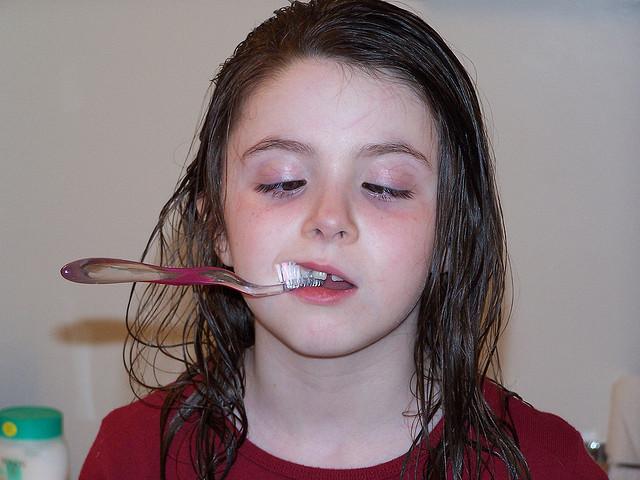What color is her shirt?
Concise answer only. Red. What is the woman doing?
Short answer required. Brushing teeth. Is she brushing?
Concise answer only. Yes. What is she doing?
Be succinct. Brushing teeth. Why are the scissor handles purple?
Give a very brief answer. No scissors. Is this girl's hair a natural color?
Answer briefly. Yes. What color is the girl's shirt?
Give a very brief answer. Red. How many bottles are pictured?
Concise answer only. 1. Is she really brushing her teeth?
Answer briefly. No. Which way is the girl looking?
Be succinct. Down. Which direction is she looking in?
Concise answer only. Down. What color is on the toothbrush?
Concise answer only. Pink. Does this appear to be the appropriate environment for conducting oral hygiene?
Keep it brief. Yes. What is the girl doing?
Answer briefly. Brushing teeth. Is she wearing glasses?
Write a very short answer. No. Why does the girl have her eyes closed?
Give a very brief answer. She doesn't. Is she smiling?
Short answer required. No. What is the object in her mouth?
Give a very brief answer. Toothbrush. What is the girl wearing on her face?
Be succinct. Toothbrush. What color is her toothbrush?
Keep it brief. Clear. Is her hair short?
Keep it brief. No. What material is the brush made out of?
Write a very short answer. Plastic. 